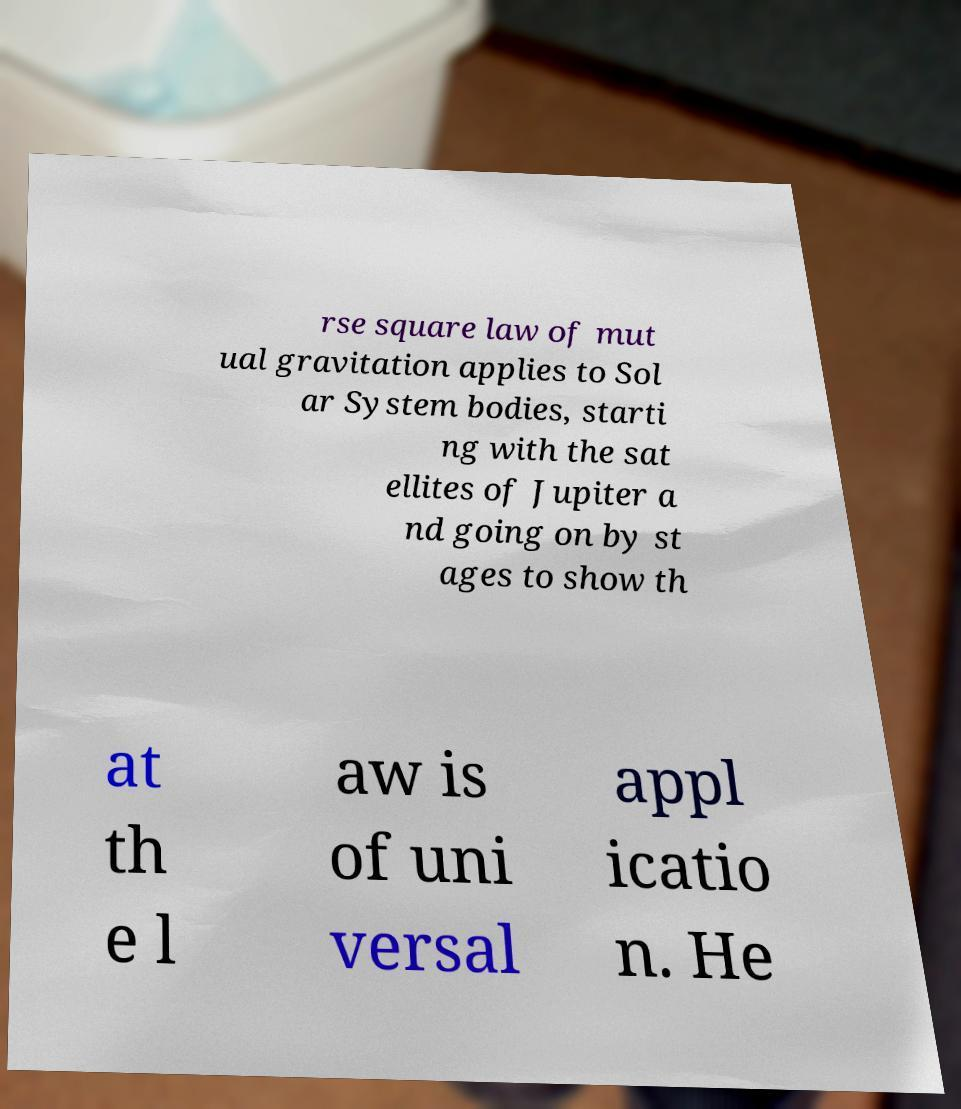Can you read and provide the text displayed in the image?This photo seems to have some interesting text. Can you extract and type it out for me? rse square law of mut ual gravitation applies to Sol ar System bodies, starti ng with the sat ellites of Jupiter a nd going on by st ages to show th at th e l aw is of uni versal appl icatio n. He 